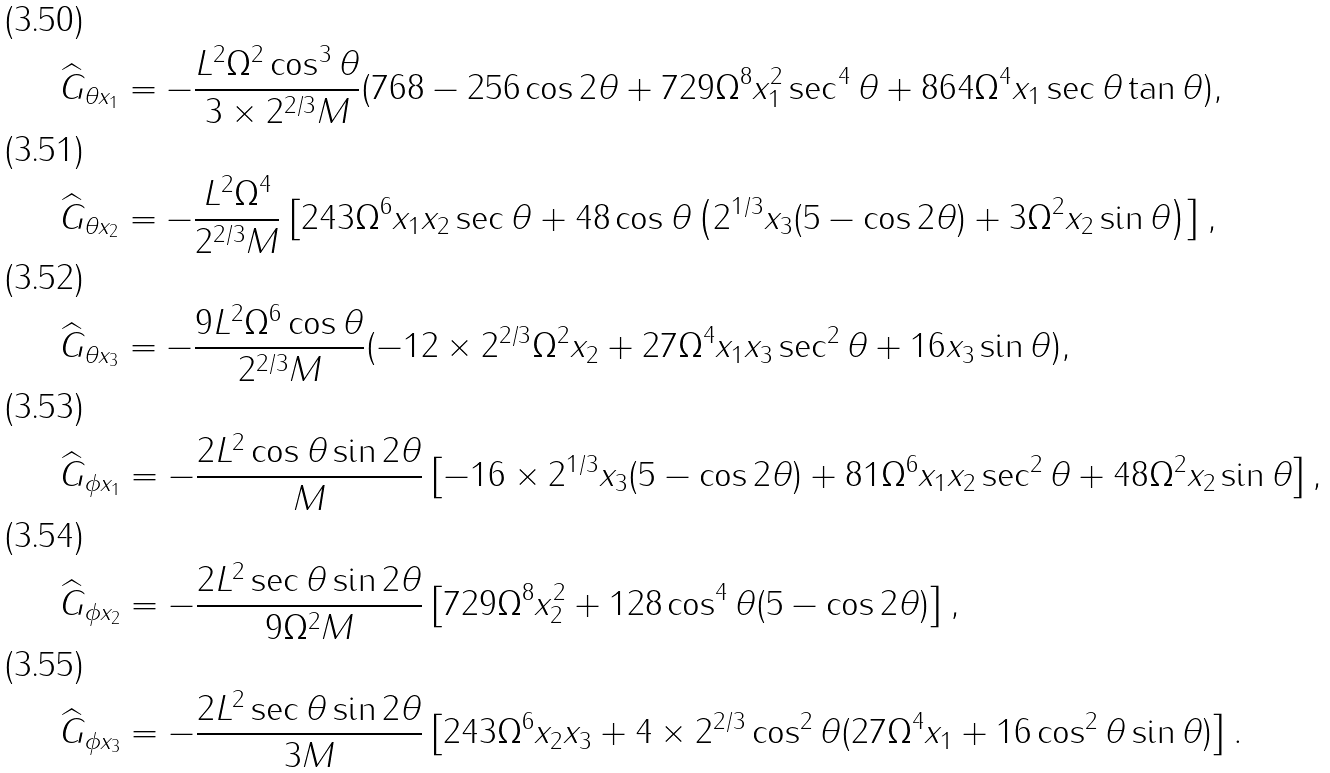Convert formula to latex. <formula><loc_0><loc_0><loc_500><loc_500>& \widehat { G } _ { \theta x _ { 1 } } = - \frac { L ^ { 2 } \Omega ^ { 2 } \cos ^ { 3 } \theta } { 3 \times 2 ^ { 2 / 3 } M } ( 7 6 8 - 2 5 6 \cos 2 \theta + 7 2 9 \Omega ^ { 8 } x _ { 1 } ^ { 2 } \sec ^ { 4 } \theta + 8 6 4 \Omega ^ { 4 } x _ { 1 } \sec \theta \tan \theta ) , \\ & \widehat { G } _ { \theta x _ { 2 } } = - \frac { L ^ { 2 } \Omega ^ { 4 } } { 2 ^ { 2 / 3 } M } \left [ 2 4 3 \Omega ^ { 6 } x _ { 1 } x _ { 2 } \sec \theta + 4 8 \cos \theta \left ( 2 ^ { 1 / 3 } x _ { 3 } ( 5 - \cos 2 \theta ) + 3 \Omega ^ { 2 } x _ { 2 } \sin \theta \right ) \right ] , \\ & \widehat { G } _ { \theta x _ { 3 } } = - \frac { 9 L ^ { 2 } \Omega ^ { 6 } \cos \theta } { 2 ^ { 2 / 3 } M } ( - 1 2 \times 2 ^ { 2 / 3 } \Omega ^ { 2 } x _ { 2 } + 2 7 \Omega ^ { 4 } x _ { 1 } x _ { 3 } \sec ^ { 2 } \theta + 1 6 x _ { 3 } \sin \theta ) , \\ & \widehat { G } _ { \phi x _ { 1 } } = - \frac { 2 L ^ { 2 } \cos \theta \sin 2 \theta } { M } \left [ - 1 6 \times 2 ^ { 1 / 3 } x _ { 3 } ( 5 - \cos 2 \theta ) + 8 1 \Omega ^ { 6 } x _ { 1 } x _ { 2 } \sec ^ { 2 } \theta + 4 8 \Omega ^ { 2 } x _ { 2 } \sin \theta \right ] , \\ & \widehat { G } _ { \phi x _ { 2 } } = - \frac { 2 L ^ { 2 } \sec \theta \sin 2 \theta } { 9 \Omega ^ { 2 } M } \left [ 7 2 9 \Omega ^ { 8 } x _ { 2 } ^ { 2 } + 1 2 8 \cos ^ { 4 } \theta ( 5 - \cos 2 \theta ) \right ] , \\ & \widehat { G } _ { \phi x _ { 3 } } = - \frac { 2 L ^ { 2 } \sec \theta \sin 2 \theta } { 3 M } \left [ 2 4 3 \Omega ^ { 6 } x _ { 2 } x _ { 3 } + 4 \times 2 ^ { 2 / 3 } \cos ^ { 2 } \theta ( 2 7 \Omega ^ { 4 } x _ { 1 } + 1 6 \cos ^ { 2 } \theta \sin \theta ) \right ] .</formula> 